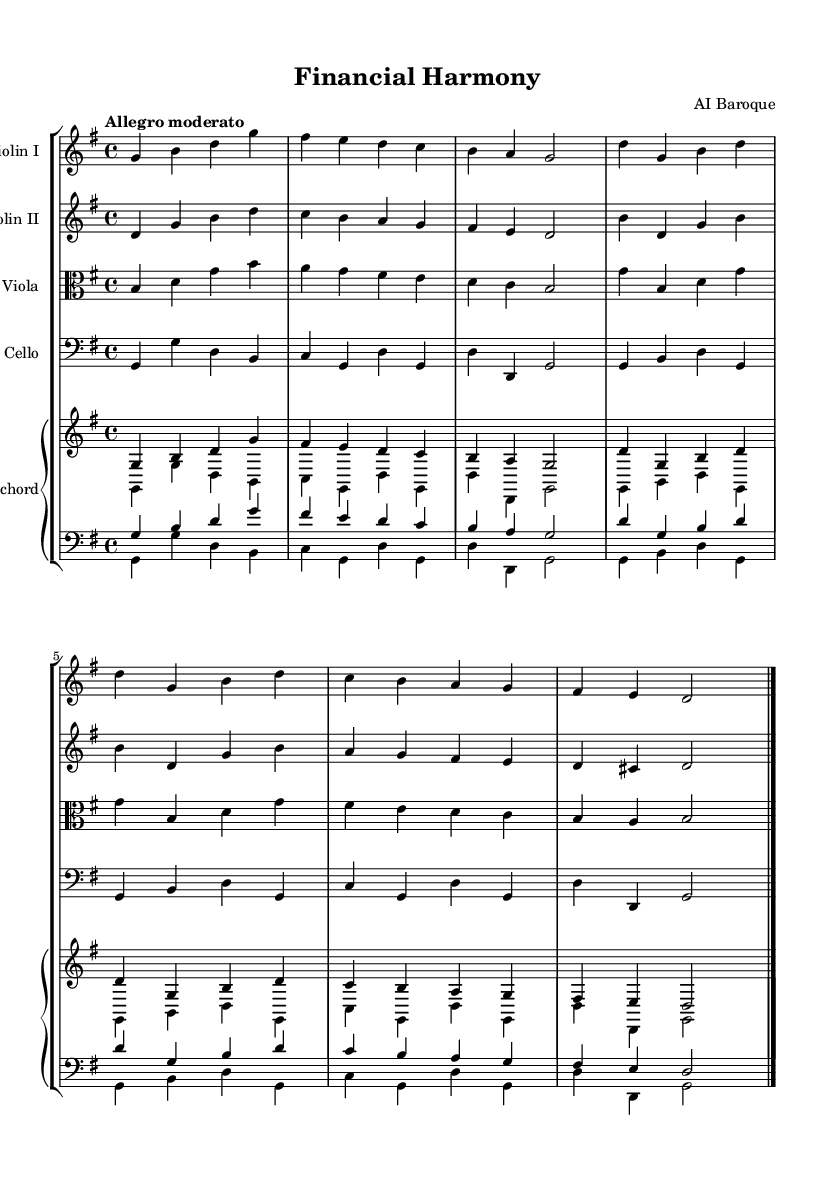What is the key signature of this music? The key signature is G major, which has one sharp (F#).
Answer: G major What is the time signature of this music? The time signature is 4/4, indicating four beats per measure.
Answer: 4/4 What is the tempo marking of this music? The tempo marking is "Allegro moderato," suggesting a moderately fast pace.
Answer: Allegro moderato How many instruments are in this ensemble? There are five instruments: two violins, one viola, one cello, and one harpsichord.
Answer: Five What is the primary texture of this piece? The primary texture is homophonic, meaning one main melody is supported by harmony.
Answer: Homophonic What is the overall dynamic style indicated in the music? The dynamics indicate a varied approach with a focus on expressive playing typical of the Baroque style.
Answer: Expressive What form does this piece exhibit typical to Baroque music? This piece exhibits a sectional form, as it has repeated phrases and variations within the sections.
Answer: Sectional 